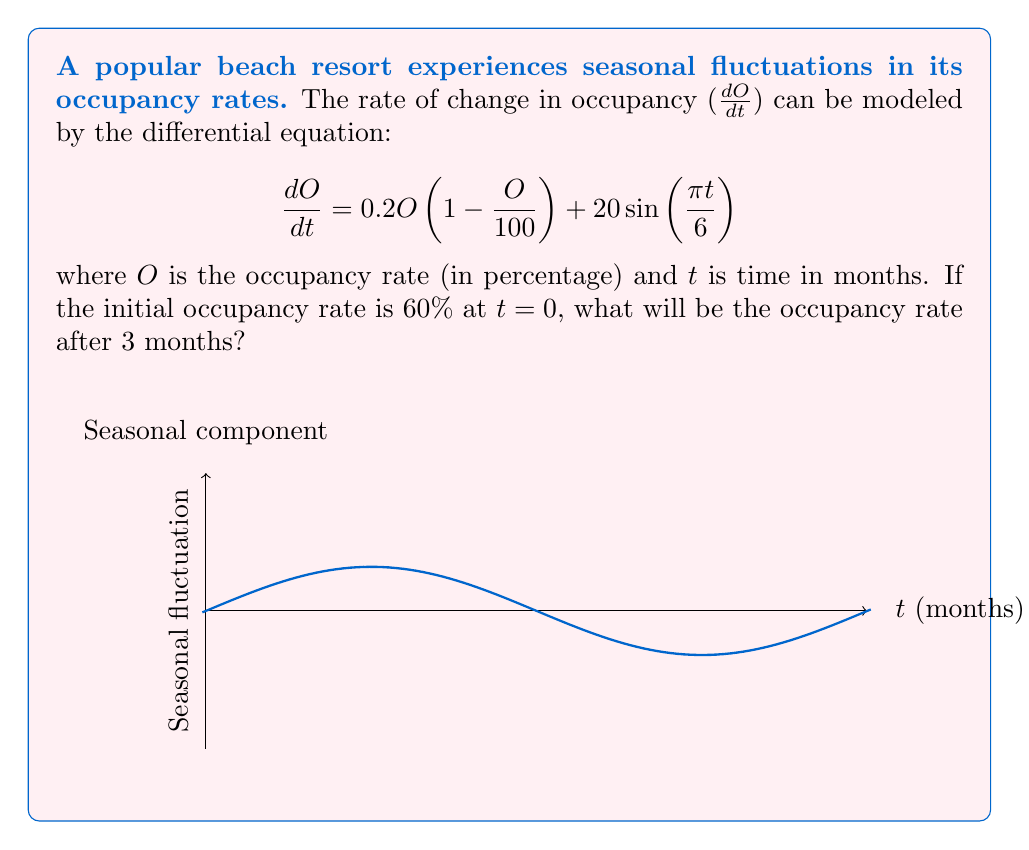What is the answer to this math problem? To solve this problem, we need to use numerical methods as the differential equation is non-linear. We'll use the 4th order Runge-Kutta method (RK4) to approximate the solution.

The RK4 method for solving $\frac{dy}{dt} = f(t, y)$ is given by:

$$y_{n+1} = y_n + \frac{1}{6}(k_1 + 2k_2 + 2k_3 + k_4)$$

where:
$$k_1 = hf(t_n, y_n)$$
$$k_2 = hf(t_n + \frac{h}{2}, y_n + \frac{k_1}{2})$$
$$k_3 = hf(t_n + \frac{h}{2}, y_n + \frac{k_2}{2})$$
$$k_4 = hf(t_n + h, y_n + k_3)$$

In our case, $f(t, O) = 0.2O(1 - \frac{O}{100}) + 20\sin(\frac{\pi t}{6})$

Let's use a step size of h = 0.1 months. We need to perform 30 iterations to reach 3 months.

Initial conditions: $t_0 = 0$, $O_0 = 60$

For each iteration:
1. Calculate $k_1$, $k_2$, $k_3$, and $k_4$
2. Update $O_{n+1} = O_n + \frac{1}{6}(k_1 + 2k_2 + 2k_3 + k_4)$
3. Update $t_{n+1} = t_n + h$

After 30 iterations, we get:
$t = 3$ months, $O \approx 84.32\%$
Answer: 84.32% 